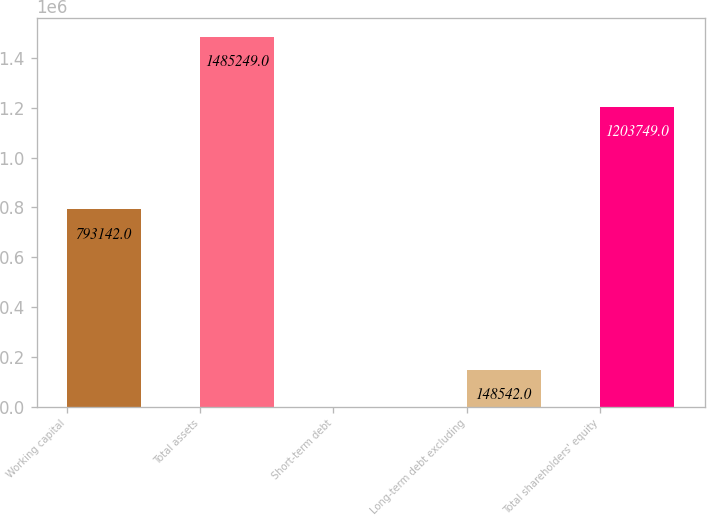Convert chart. <chart><loc_0><loc_0><loc_500><loc_500><bar_chart><fcel>Working capital<fcel>Total assets<fcel>Short-term debt<fcel>Long-term debt excluding<fcel>Total shareholders' equity<nl><fcel>793142<fcel>1.48525e+06<fcel>19<fcel>148542<fcel>1.20375e+06<nl></chart> 